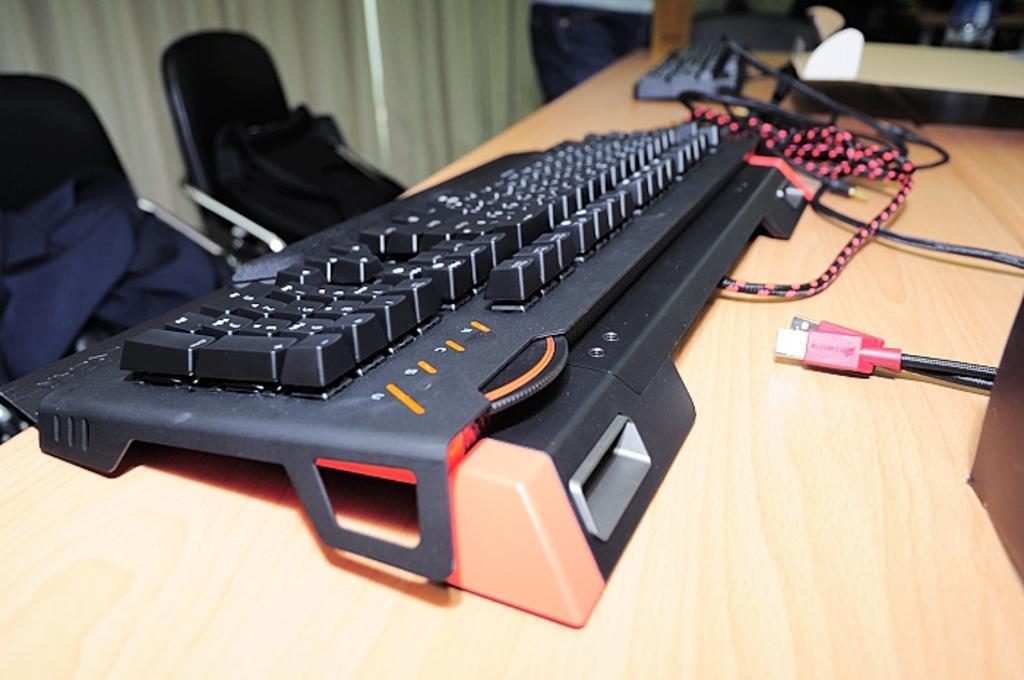Please provide a concise description of this image. In this image I see a keyboard, few wires and 2 chairs over here. 